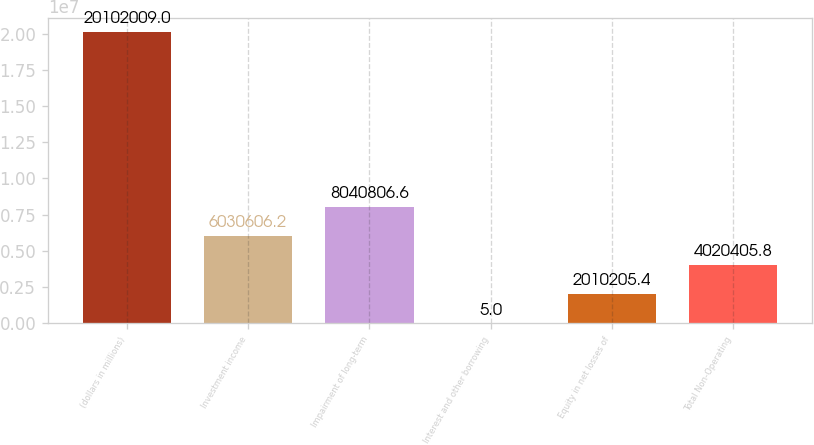Convert chart to OTSL. <chart><loc_0><loc_0><loc_500><loc_500><bar_chart><fcel>(dollars in millions)<fcel>Investment income<fcel>Impairment of long-term<fcel>Interest and other borrowing<fcel>Equity in net losses of<fcel>Total Non-Operating<nl><fcel>2.0102e+07<fcel>6.03061e+06<fcel>8.04081e+06<fcel>5<fcel>2.01021e+06<fcel>4.02041e+06<nl></chart> 